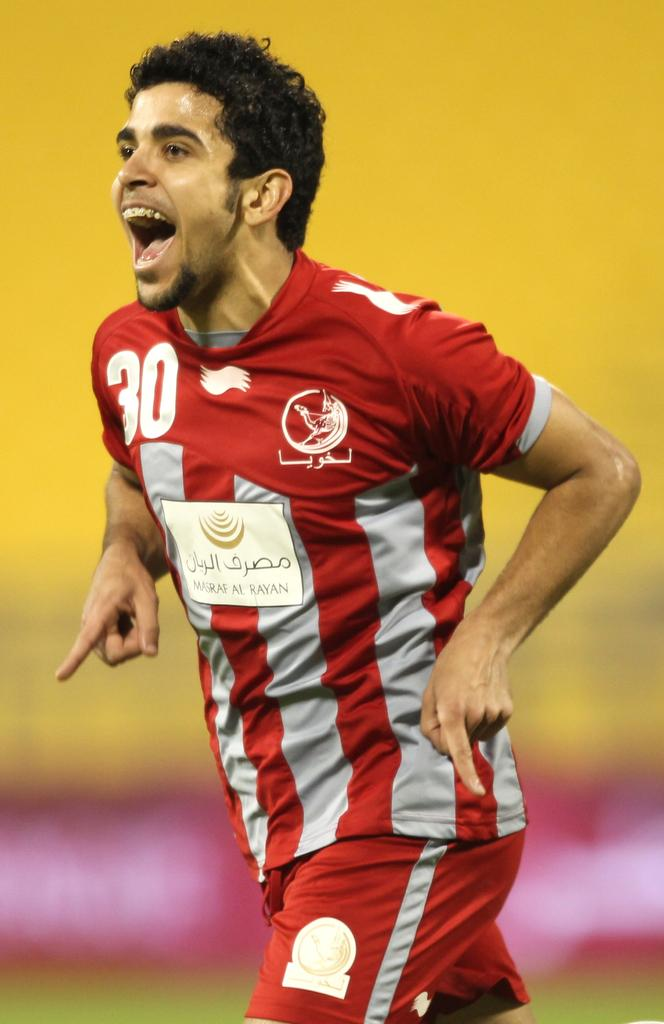<image>
Provide a brief description of the given image. the number 30 is on the red and gray shirt 